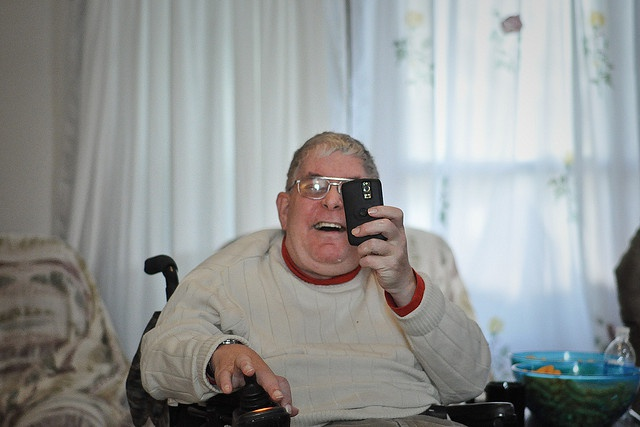Describe the objects in this image and their specific colors. I can see people in gray, darkgray, and black tones, chair in gray and black tones, chair in gray, black, darkgray, and maroon tones, bowl in gray, black, and teal tones, and cell phone in gray and black tones in this image. 